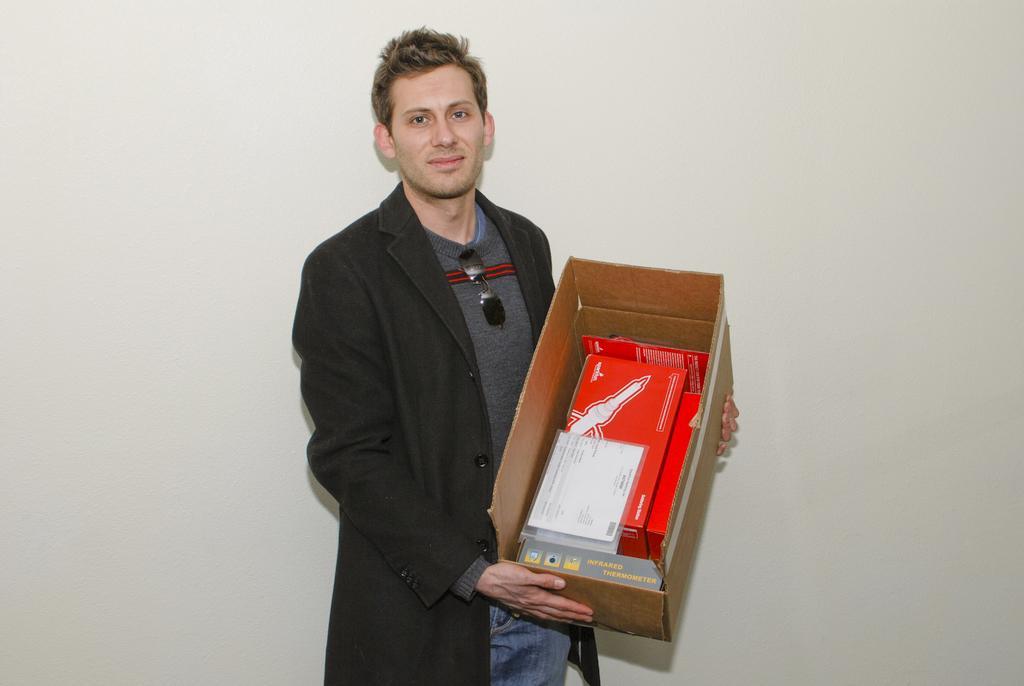How would you summarize this image in a sentence or two? In the middle of the image a man is standing and holding a box and smiling. Behind him there is a wall. 